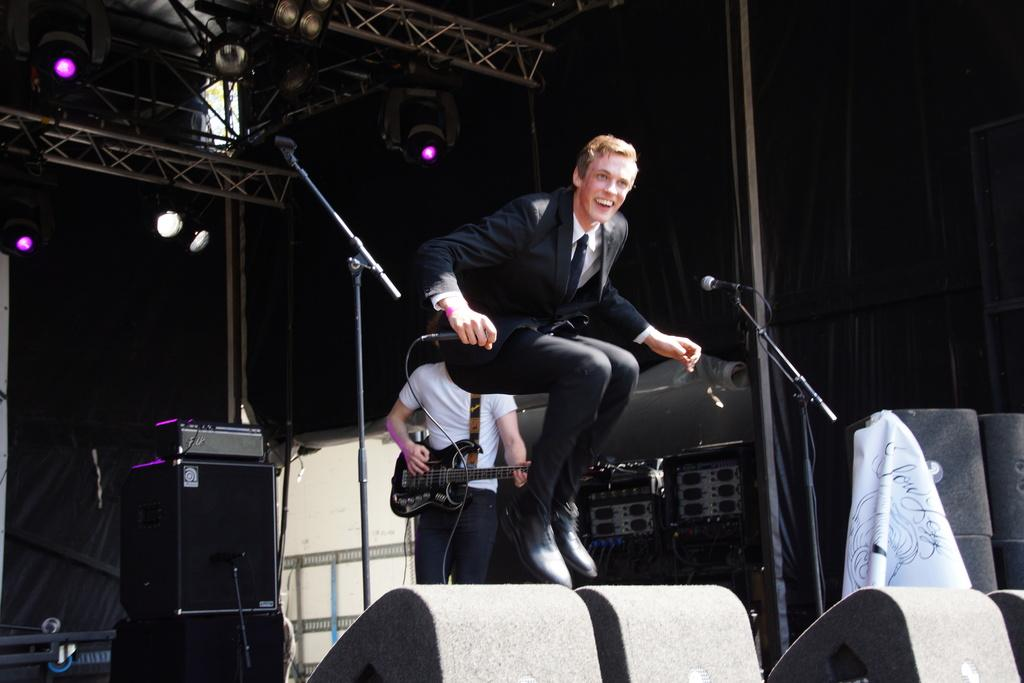What is the man in the image doing? The man is jumping in the image. What is the man holding in his hand? The man is holding a microphone in his hand. Can you describe the second man in the image? The second man is playing a guitar in the image. How is the second man positioned? The second man is positioned on his back. What type of scale can be seen in the image? There is no scale present in the image. Is there any indication that the men are under attack in the image? There is no indication of an attack in the image; the men are simply performing their respective activities. 